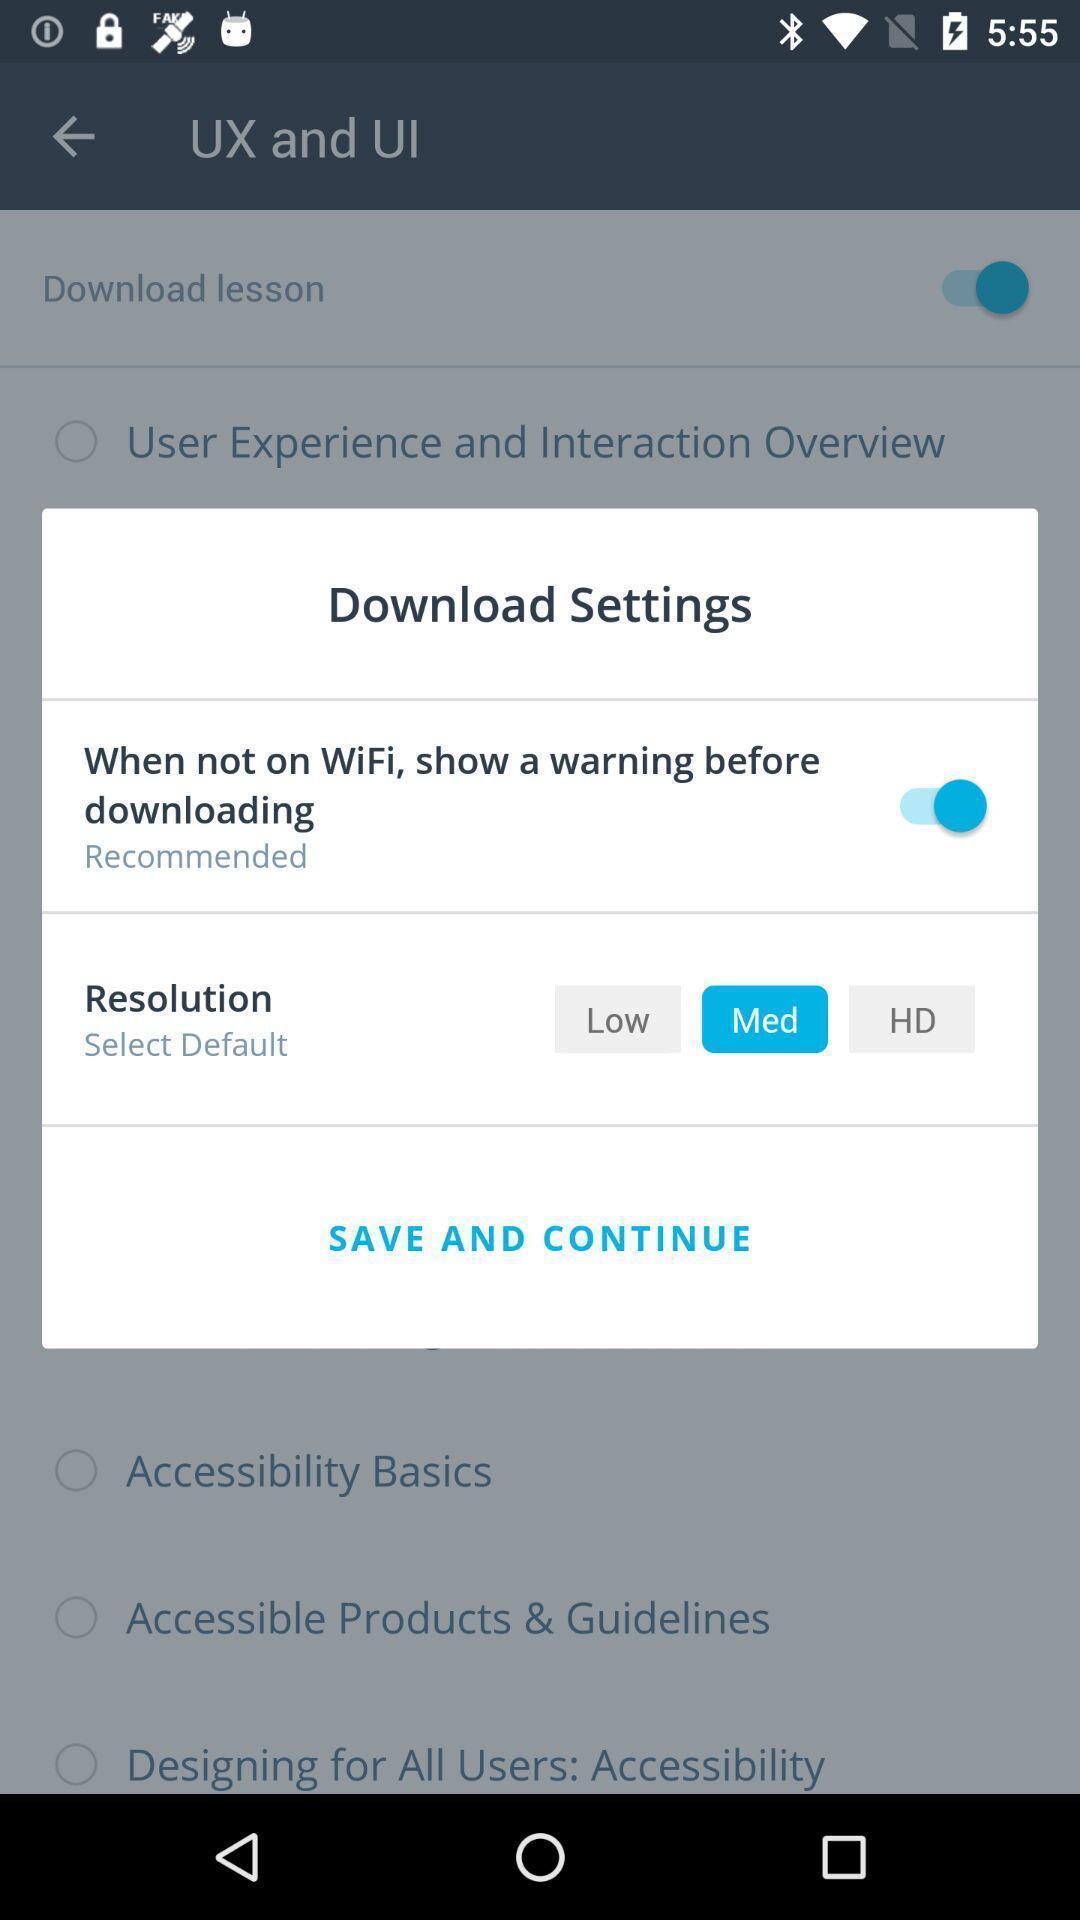What can you discern from this picture? Pop-up displaying the download settings. 